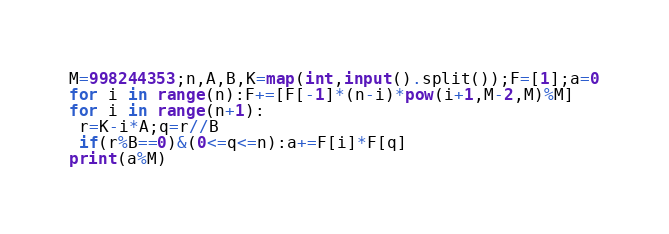<code> <loc_0><loc_0><loc_500><loc_500><_Python_>M=998244353;n,A,B,K=map(int,input().split());F=[1];a=0
for i in range(n):F+=[F[-1]*(n-i)*pow(i+1,M-2,M)%M]
for i in range(n+1):
 r=K-i*A;q=r//B
 if(r%B==0)&(0<=q<=n):a+=F[i]*F[q]
print(a%M)</code> 